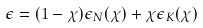Convert formula to latex. <formula><loc_0><loc_0><loc_500><loc_500>\epsilon = ( 1 - \chi ) \epsilon _ { N } ( \chi ) + \chi \epsilon _ { K } ( \chi )</formula> 